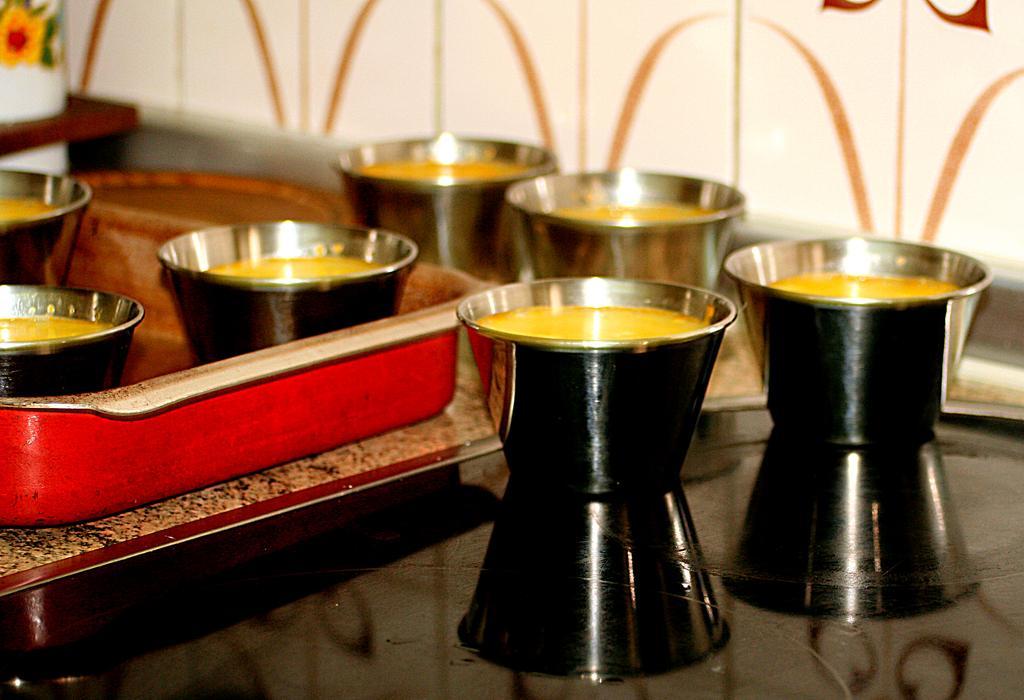Describe this image in one or two sentences. In this image there are bowls on the floor and in a tray. There is food in the bowls. At the top there is a wall. 